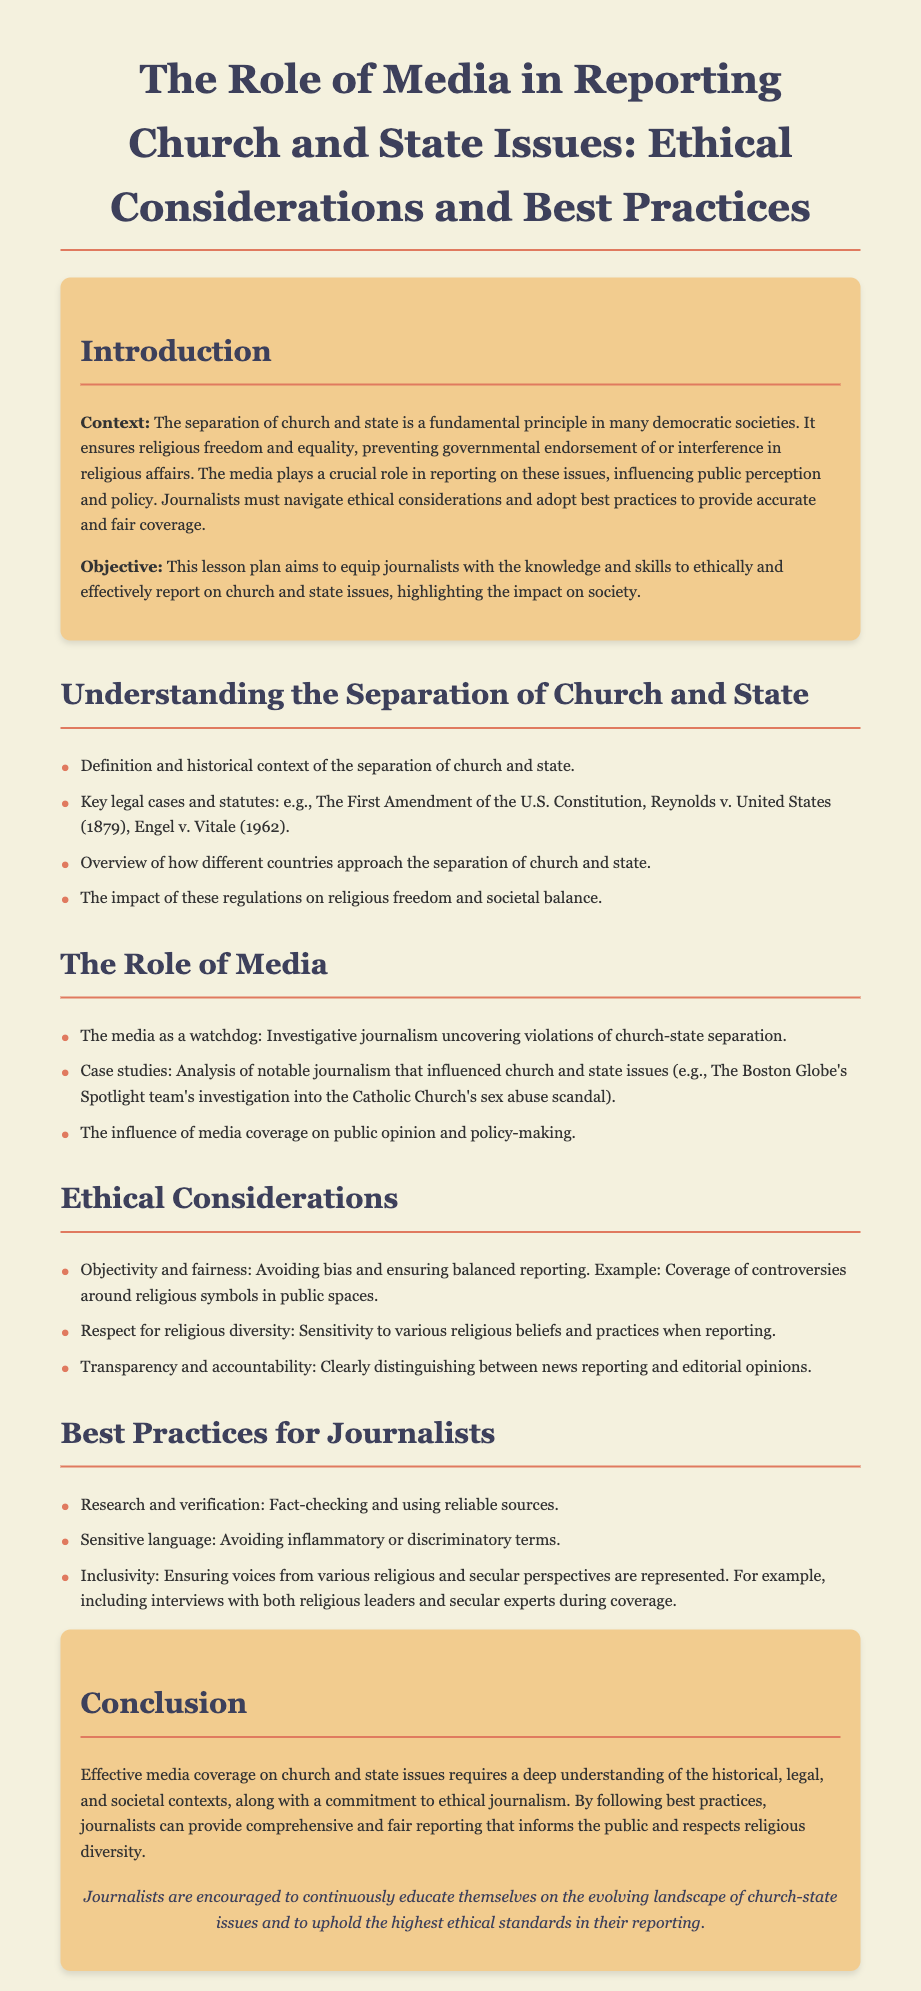What is the main objective of this lesson plan? The objective is to equip journalists with the knowledge and skills to ethically and effectively report on church and state issues, highlighting the impact on society.
Answer: To equip journalists with knowledge and skills What is the definition of the separation of church and state? The separation ensures religious freedom and equality, preventing governmental endorsement of or interference in religious affairs.
Answer: Fundamental principle What legal case is mentioned from 1962? Engel v. Vitale
Answer: Engel v. Vitale What type of journalism does the media serve as, according to the document? The media serves as a watchdog.
Answer: Watchdog Which notable investigation is cited as a case study? The Boston Globe's Spotlight team's investigation into the Catholic Church's sex abuse scandal.
Answer: The Boston Globe's Spotlight team's investigation What ethical consideration involves avoiding bias? Objectivity and fairness
Answer: Objectivity and fairness What is recommended regarding language sensitivity? Avoiding inflammatory or discriminatory terms.
Answer: Avoiding inflammatory terms What is emphasized for inclusive reporting? Ensuring voices from various religious and secular perspectives are represented.
Answer: Inclusivity 